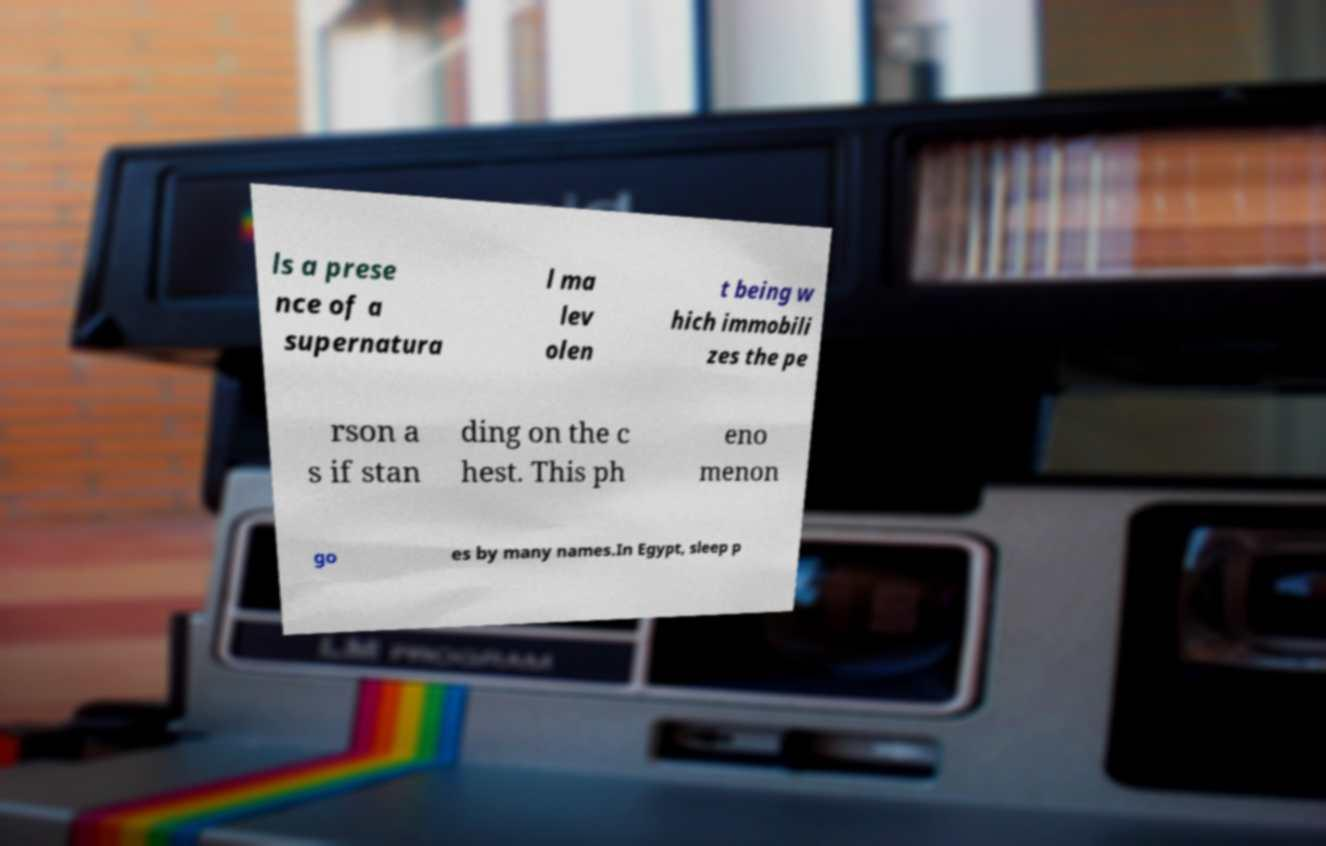Could you assist in decoding the text presented in this image and type it out clearly? ls a prese nce of a supernatura l ma lev olen t being w hich immobili zes the pe rson a s if stan ding on the c hest. This ph eno menon go es by many names.In Egypt, sleep p 